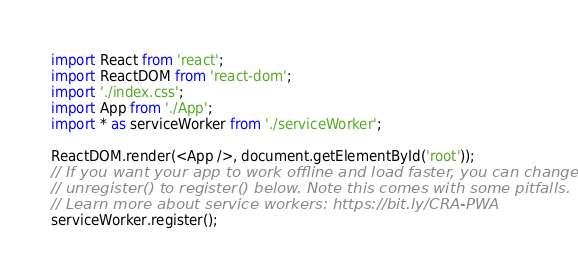<code> <loc_0><loc_0><loc_500><loc_500><_JavaScript_>import React from 'react';
import ReactDOM from 'react-dom';
import './index.css';
import App from './App';
import * as serviceWorker from './serviceWorker';

ReactDOM.render(<App />, document.getElementById('root'));
// If you want your app to work offline and load faster, you can change
// unregister() to register() below. Note this comes with some pitfalls.
// Learn more about service workers: https://bit.ly/CRA-PWA
serviceWorker.register();
</code> 